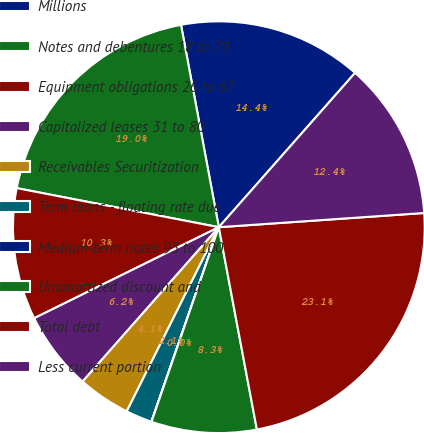<chart> <loc_0><loc_0><loc_500><loc_500><pie_chart><fcel>Millions<fcel>Notes and debentures 18 to 79<fcel>Equipment obligations 26 to 67<fcel>Capitalized leases 31 to 80<fcel>Receivables Securitization<fcel>Term loans - floating rate due<fcel>Medium-term notes 93 to 100<fcel>Unamortized discount and<fcel>Total debt<fcel>Less current portion<nl><fcel>14.45%<fcel>19.02%<fcel>10.33%<fcel>6.2%<fcel>4.13%<fcel>2.07%<fcel>0.01%<fcel>8.26%<fcel>23.14%<fcel>12.39%<nl></chart> 